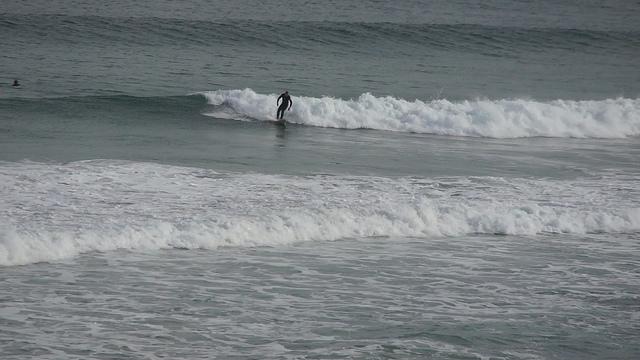How many waves are in the picture?
Write a very short answer. 3. How many people are in the water?
Give a very brief answer. 2. What is the man doing?
Give a very brief answer. Surfing. 